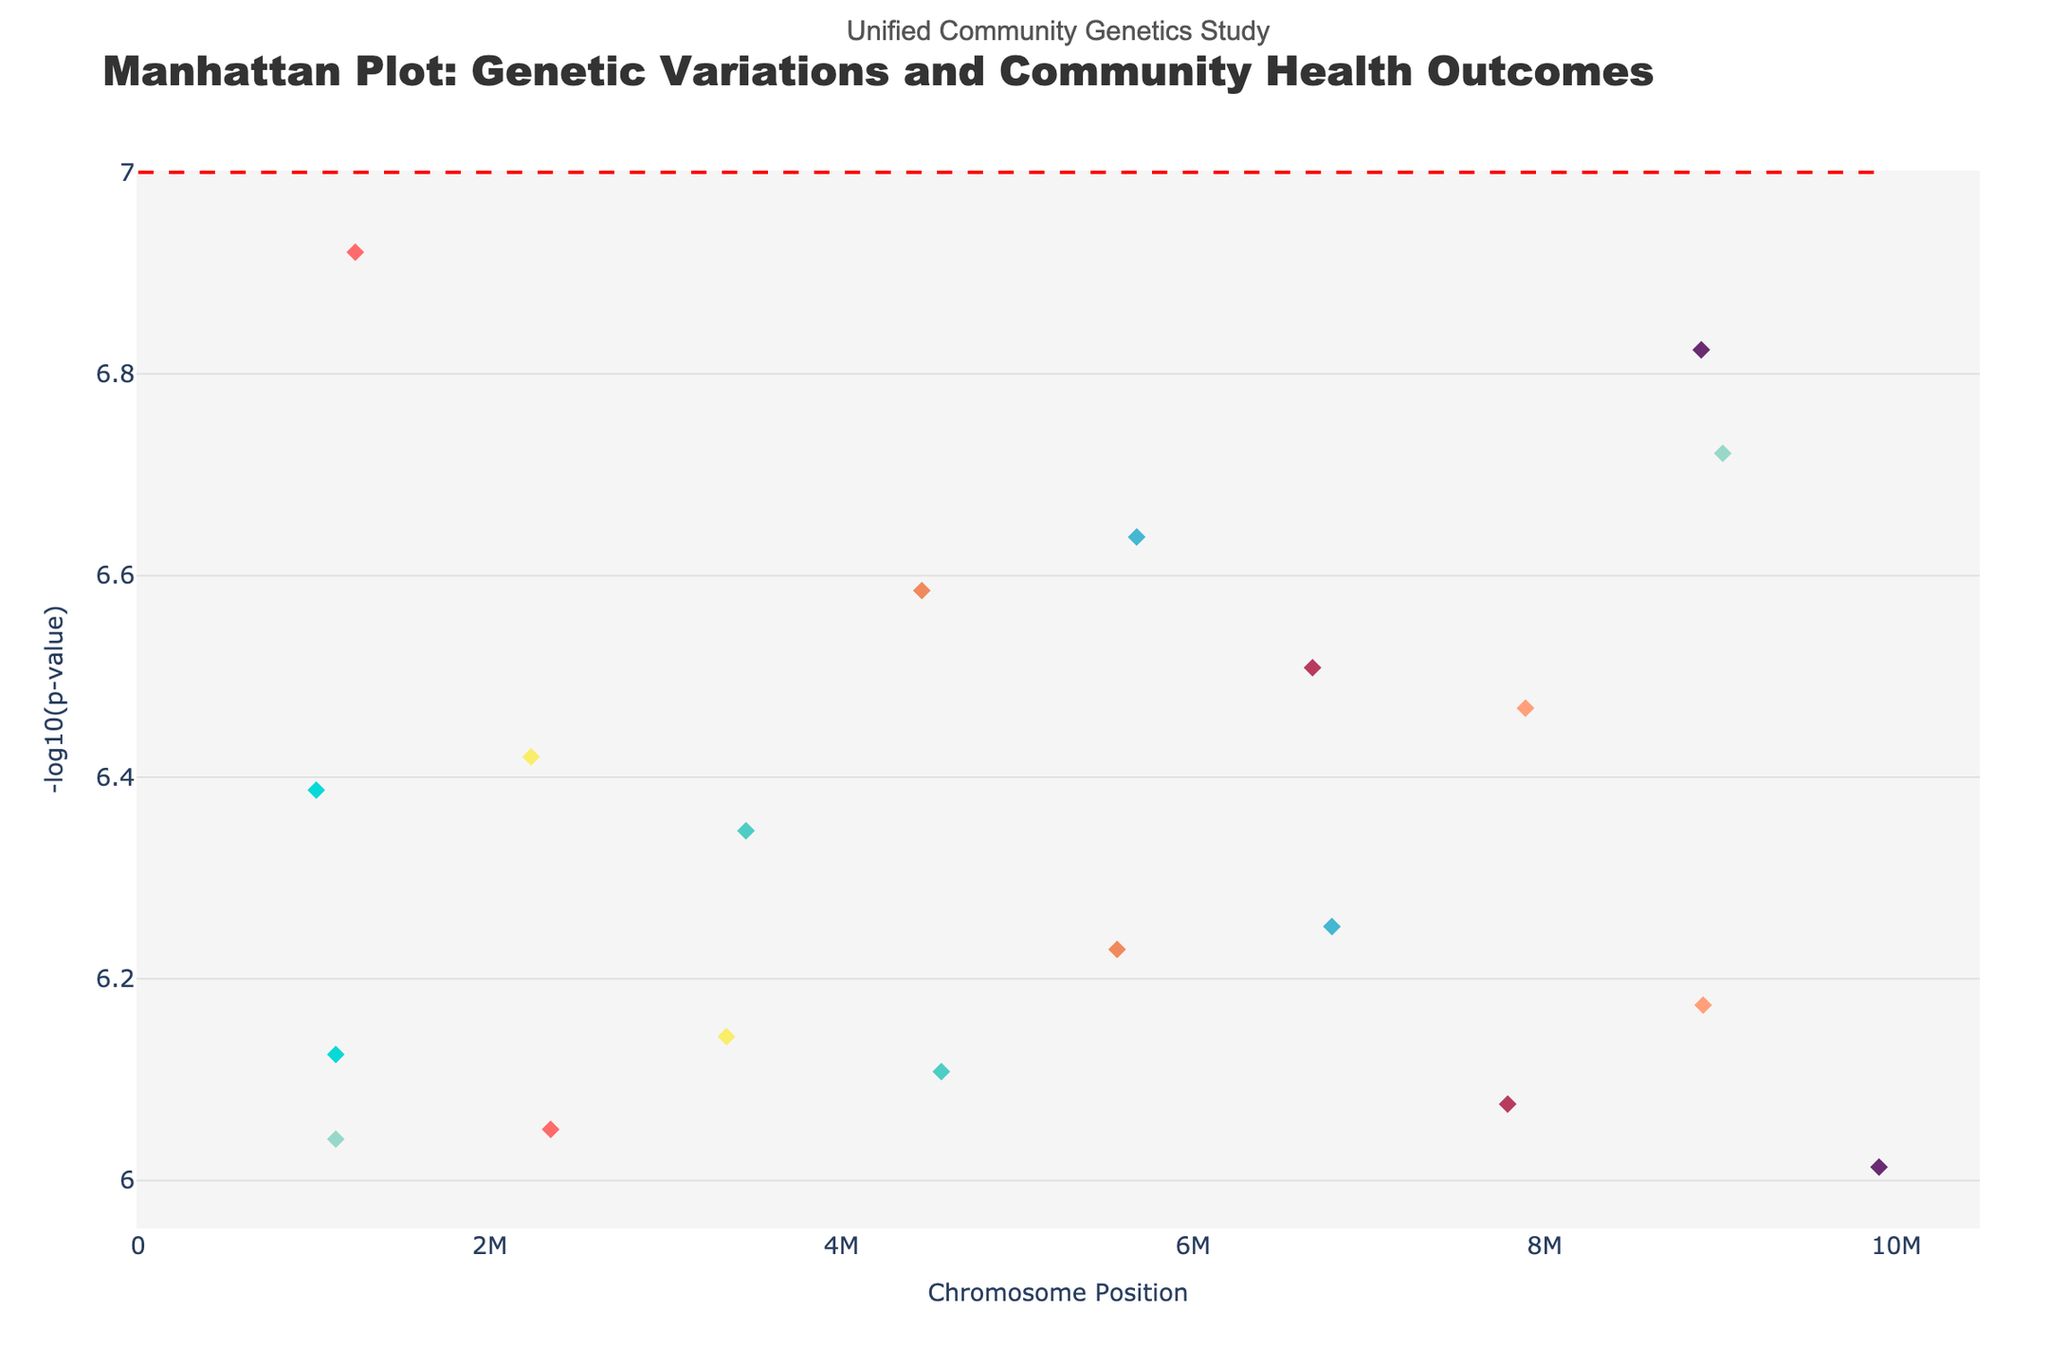What's the title of the figure? The title of the figure is displayed at the top of the plot, which reads "Manhattan Plot: Genetic Variations and Community Health Outcomes."
Answer: Manhattan Plot: Genetic Variations and Community Health Outcomes What does the y-axis represent? The y-axis is labeled with "-log10(p-value)," which represents the negative logarithm of the p-values, indicating the significance of the genetic variations.
Answer: -log10(p-value) What is the color used to represent Chromosome 9? Each chromosome is represented by a different color and Chromosome 9 is colored in purple as shown in the color legend.
Answer: purple How many chromosomes are represented in the plot? By examining the distinct traces and colors, it's clear that the plot includes data from 10 different chromosomes.
Answer: 10 Which neighborhood is associated with the SNP having the lowest p-value on Chromosome 1? The SNP with the lowest p-value within a chromosome will have the highest -log10(p) value on the y-axis. For Chromosome 1, the SNP rs1234567 has the highest -log10(p) and is associated with Downtown.
Answer: Downtown What is the position of the SNP rs9901234 in the Medical Center neighborhood? By identifying the SNP rs9901234 from the hover information, it's clear that its position is given as 9901234.
Answer: 9901234 Which chromosome has the SNP with the highest -log10(p-value)? The highest point on the y-axis indicates the most significant p-value. Observing the tallest point, it corresponds to SNP rs9901234 on Chromosome 9.
Answer: Chromosome 9 What is the color of the threshold line, and what does it signify? The threshold line is colored red and runs horizontally across the plot. It typically represents a significance threshold, here set at -log10(p-value) = 7.
Answer: red, significance threshold How many SNPs have a p-value smaller than the significance threshold? SNPs with -log10(p-values) greater than 7 are above the red threshold line. Counting these points indicates there are six such SNPs.
Answer: 6 Among the SNPs plotted, which one has the largest -log10(p-value) and what is its neighborhood? The SNP with the largest -log10(p) value will be plotted the highest on the y-axis. This point corresponds to SNP rs9901234, associated with the Medical Center.
Answer: rs9901234, Medical Center 